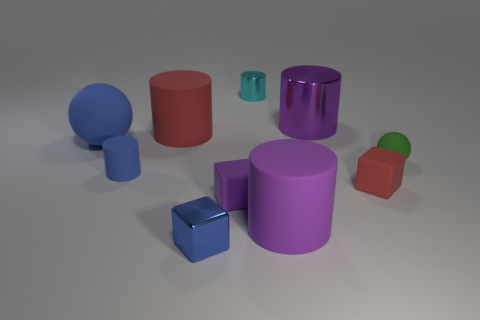Subtract all yellow spheres. How many purple cylinders are left? 2 Subtract all metallic cylinders. How many cylinders are left? 3 Subtract all red cylinders. How many cylinders are left? 4 Subtract all cubes. How many objects are left? 7 Subtract all green cylinders. Subtract all blue cubes. How many cylinders are left? 5 Add 5 large purple shiny cylinders. How many large purple shiny cylinders are left? 6 Add 9 small rubber cylinders. How many small rubber cylinders exist? 10 Subtract 0 red balls. How many objects are left? 10 Subtract all small purple rubber cubes. Subtract all blocks. How many objects are left? 6 